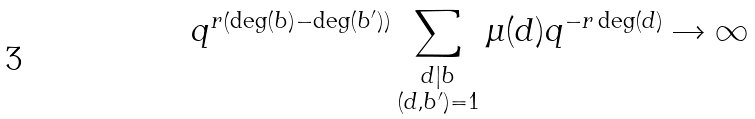Convert formula to latex. <formula><loc_0><loc_0><loc_500><loc_500>q ^ { r \left ( \deg ( b ) - \deg ( b ^ { \prime } ) \right ) } \sum _ { \substack { d | b \\ ( d , b ^ { \prime } ) = 1 } } \mu ( d ) q ^ { - r \deg ( d ) } \rightarrow \infty</formula> 